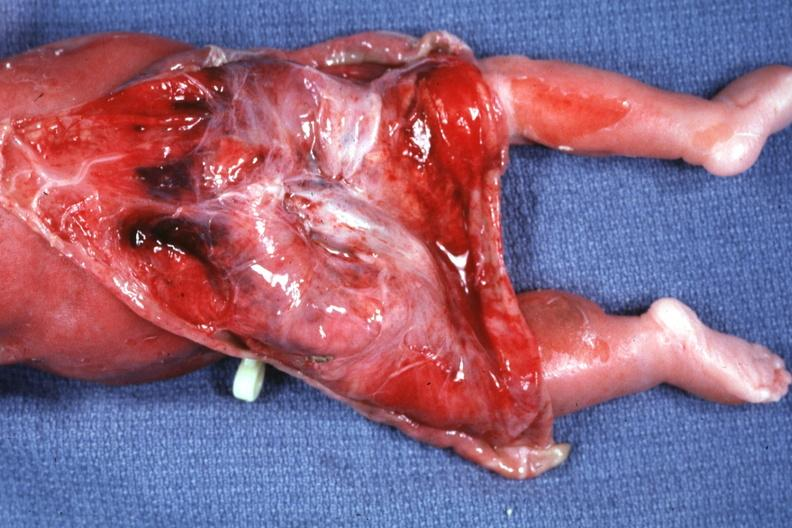s skin over back a buttocks reflected to show large tumor mass?
Answer the question using a single word or phrase. Yes 